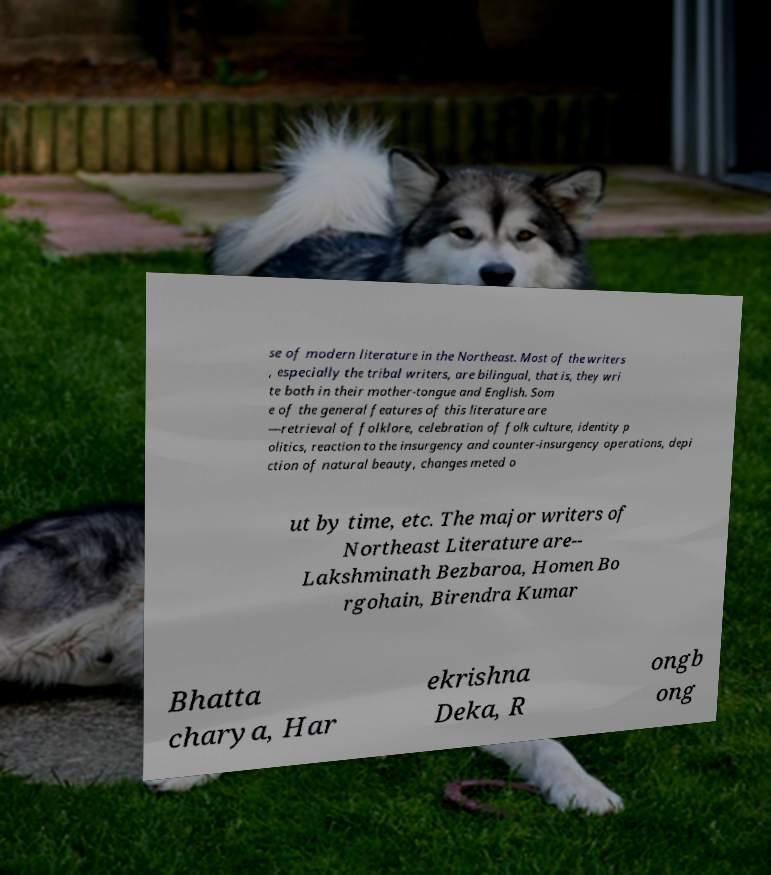For documentation purposes, I need the text within this image transcribed. Could you provide that? se of modern literature in the Northeast. Most of the writers , especially the tribal writers, are bilingual, that is, they wri te both in their mother-tongue and English. Som e of the general features of this literature are —retrieval of folklore, celebration of folk culture, identity p olitics, reaction to the insurgency and counter-insurgency operations, depi ction of natural beauty, changes meted o ut by time, etc. The major writers of Northeast Literature are-- Lakshminath Bezbaroa, Homen Bo rgohain, Birendra Kumar Bhatta charya, Har ekrishna Deka, R ongb ong 